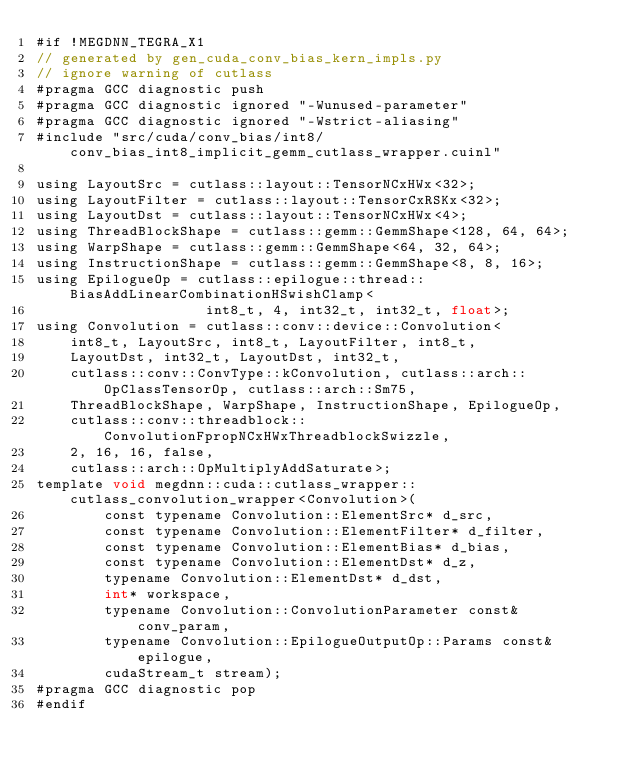<code> <loc_0><loc_0><loc_500><loc_500><_Cuda_>#if !MEGDNN_TEGRA_X1
// generated by gen_cuda_conv_bias_kern_impls.py
// ignore warning of cutlass
#pragma GCC diagnostic push
#pragma GCC diagnostic ignored "-Wunused-parameter"
#pragma GCC diagnostic ignored "-Wstrict-aliasing"
#include "src/cuda/conv_bias/int8/conv_bias_int8_implicit_gemm_cutlass_wrapper.cuinl"

using LayoutSrc = cutlass::layout::TensorNCxHWx<32>;
using LayoutFilter = cutlass::layout::TensorCxRSKx<32>;
using LayoutDst = cutlass::layout::TensorNCxHWx<4>;
using ThreadBlockShape = cutlass::gemm::GemmShape<128, 64, 64>;
using WarpShape = cutlass::gemm::GemmShape<64, 32, 64>;
using InstructionShape = cutlass::gemm::GemmShape<8, 8, 16>;
using EpilogueOp = cutlass::epilogue::thread::BiasAddLinearCombinationHSwishClamp<
                    int8_t, 4, int32_t, int32_t, float>;
using Convolution = cutlass::conv::device::Convolution<
    int8_t, LayoutSrc, int8_t, LayoutFilter, int8_t, 
    LayoutDst, int32_t, LayoutDst, int32_t, 
    cutlass::conv::ConvType::kConvolution, cutlass::arch::OpClassTensorOp, cutlass::arch::Sm75, 
    ThreadBlockShape, WarpShape, InstructionShape, EpilogueOp, 
    cutlass::conv::threadblock::ConvolutionFpropNCxHWxThreadblockSwizzle, 
    2, 16, 16, false, 
    cutlass::arch::OpMultiplyAddSaturate>;
template void megdnn::cuda::cutlass_wrapper::cutlass_convolution_wrapper<Convolution>(
        const typename Convolution::ElementSrc* d_src, 
        const typename Convolution::ElementFilter* d_filter, 
        const typename Convolution::ElementBias* d_bias, 
        const typename Convolution::ElementDst* d_z, 
        typename Convolution::ElementDst* d_dst, 
        int* workspace, 
        typename Convolution::ConvolutionParameter const& conv_param, 
        typename Convolution::EpilogueOutputOp::Params const& epilogue, 
        cudaStream_t stream);
#pragma GCC diagnostic pop
#endif
</code> 